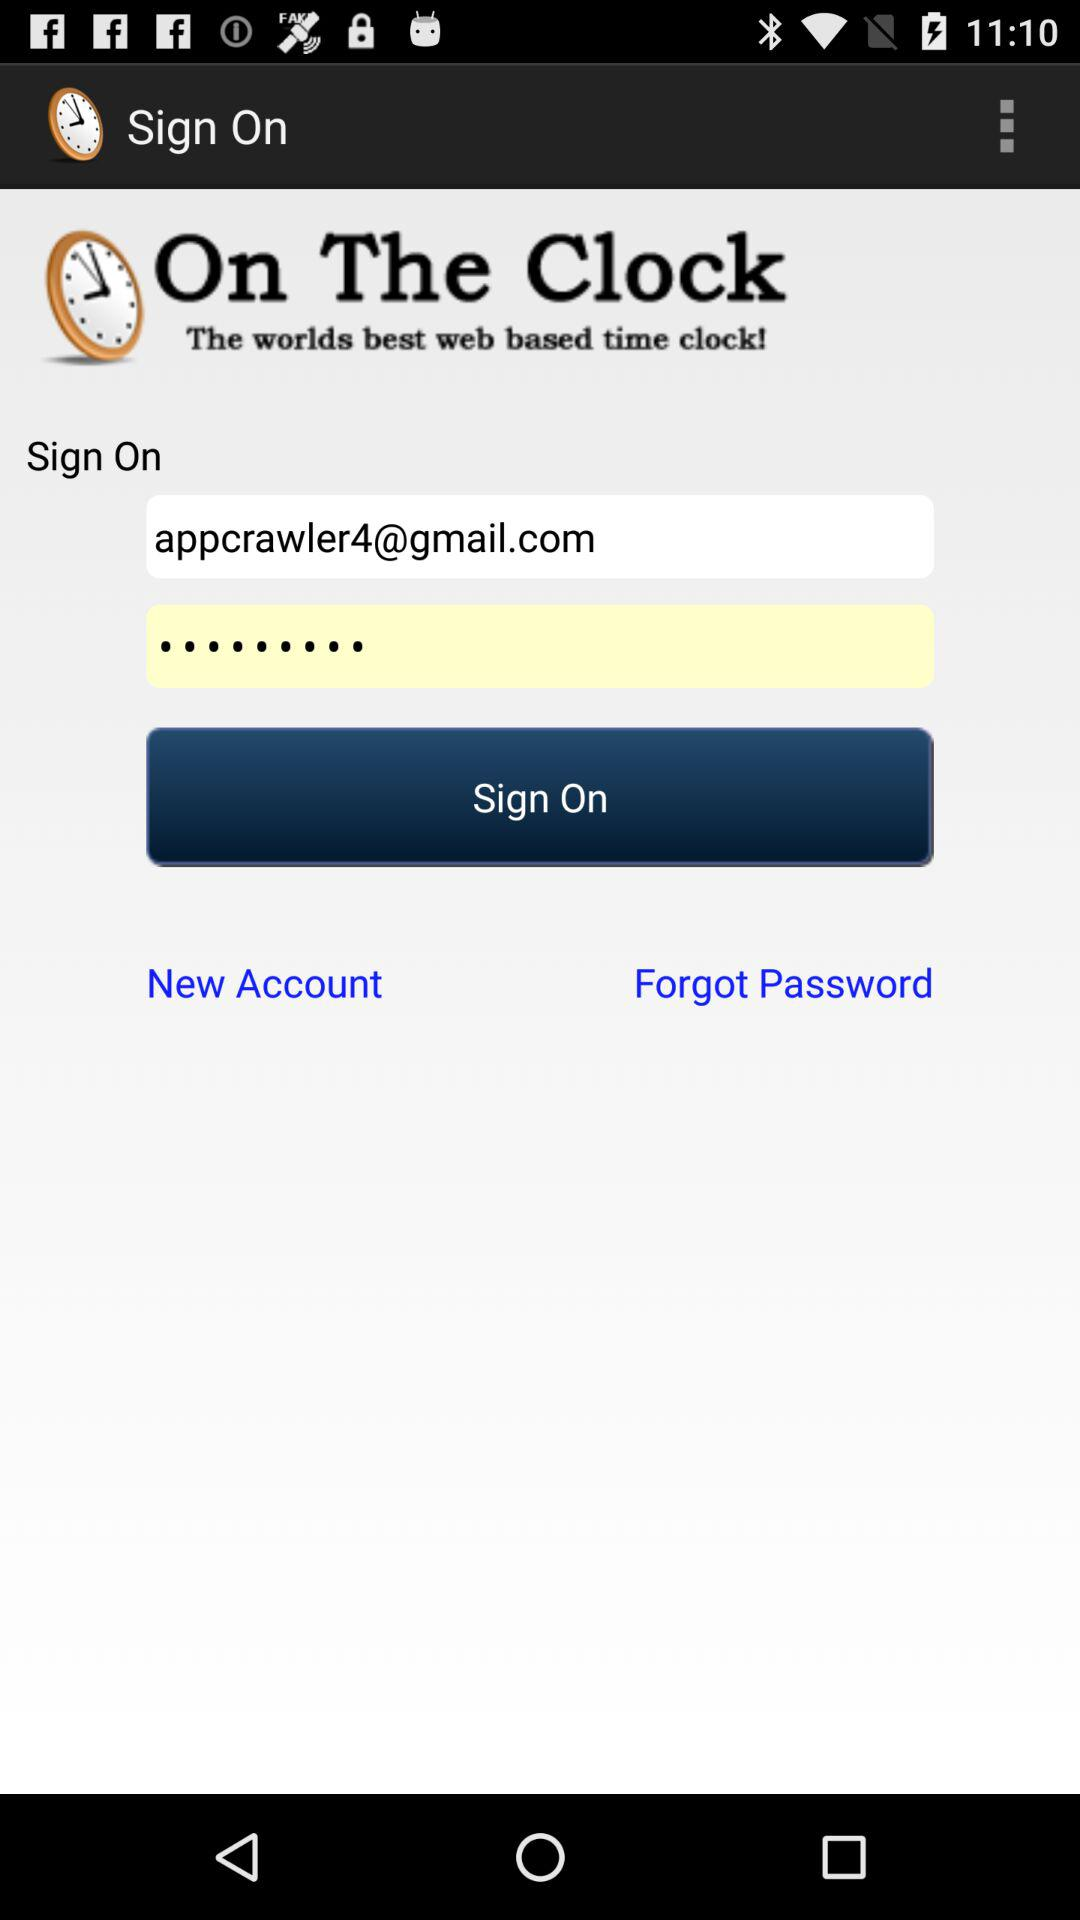What is the email address? The email address is appcrawler4@gmail.com. 